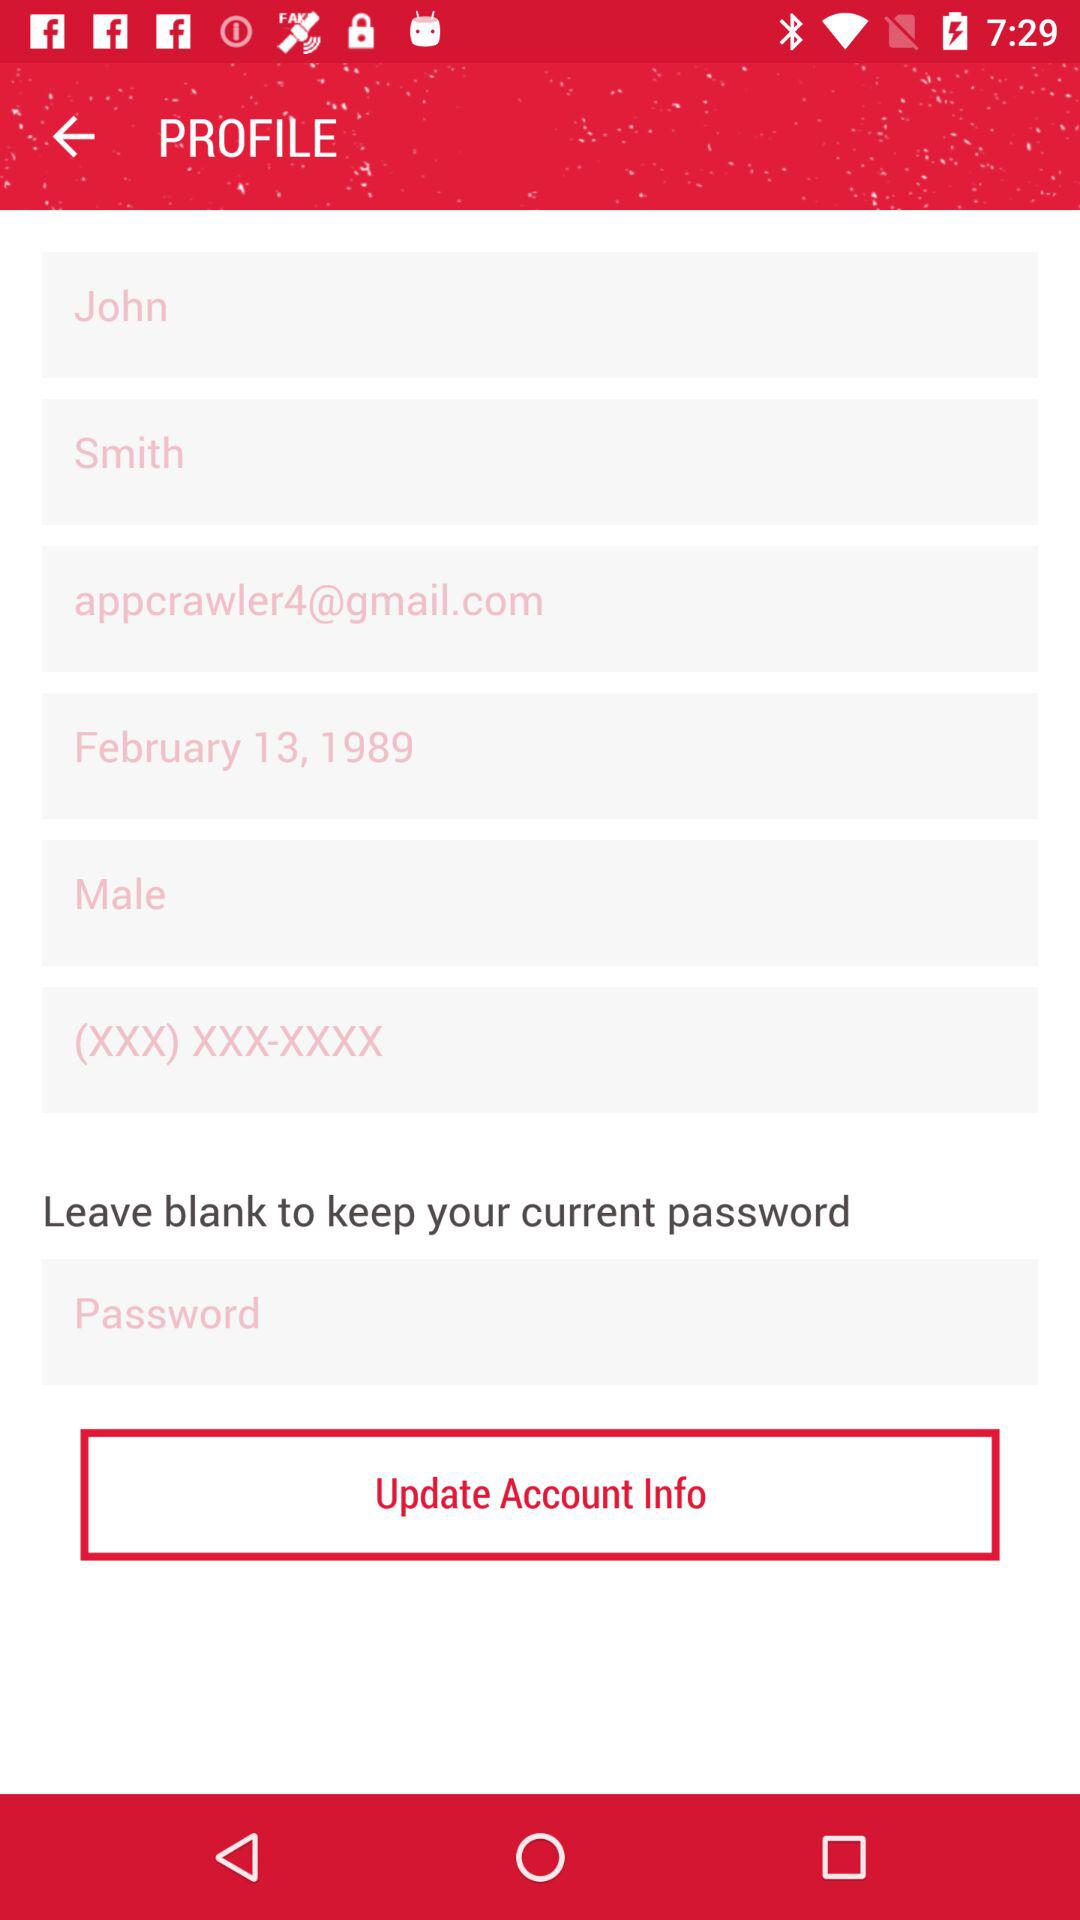What is the profile name? The profile name is John Smith. 